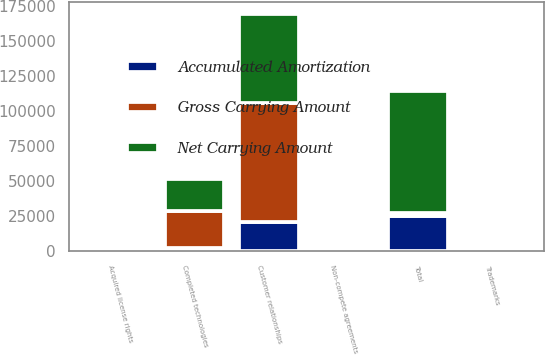<chart> <loc_0><loc_0><loc_500><loc_500><stacked_bar_chart><ecel><fcel>Completed technologies<fcel>Customer relationships<fcel>Non-compete agreements<fcel>Trademarks<fcel>Acquired license rights<fcel>Total<nl><fcel>Gross Carrying Amount<fcel>25831<fcel>84400<fcel>1600<fcel>500<fcel>490<fcel>1600<nl><fcel>Accumulated Amortization<fcel>2631<fcel>21029<fcel>1108<fcel>109<fcel>444<fcel>25321<nl><fcel>Net Carrying Amount<fcel>23200<fcel>63371<fcel>492<fcel>391<fcel>46<fcel>87500<nl></chart> 